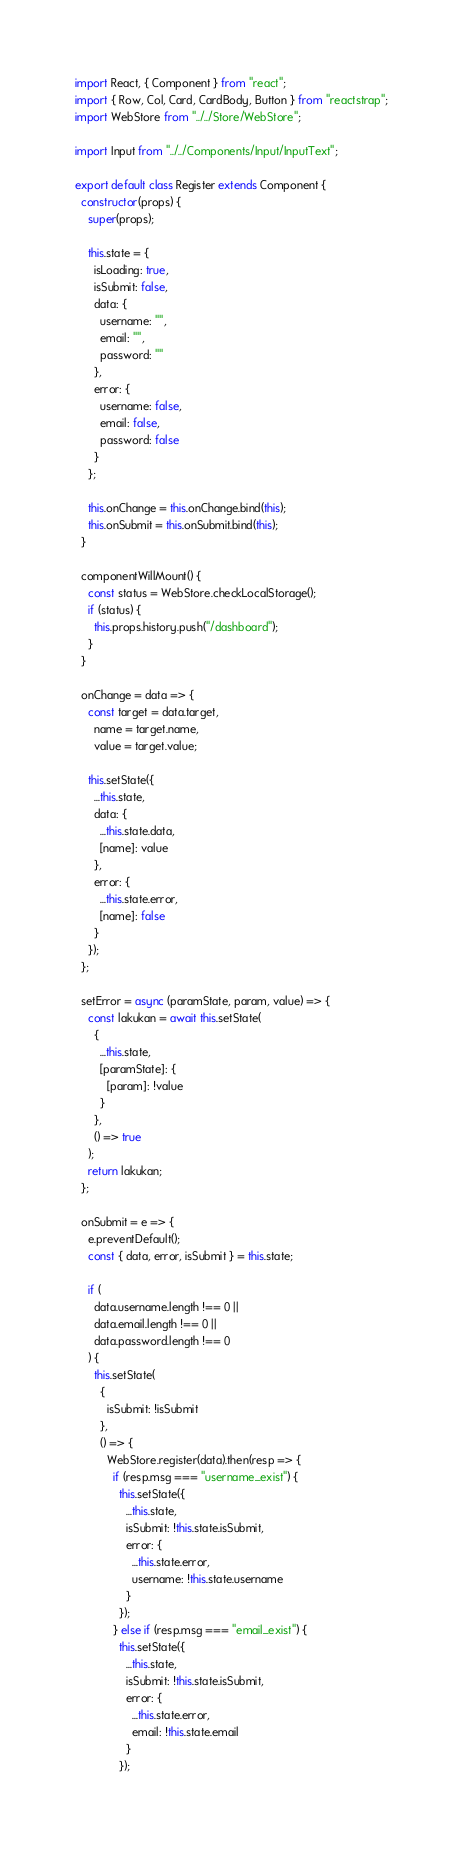Convert code to text. <code><loc_0><loc_0><loc_500><loc_500><_JavaScript_>import React, { Component } from "react";
import { Row, Col, Card, CardBody, Button } from "reactstrap";
import WebStore from "../../Store/WebStore";

import Input from "../../Components/Input/InputText";

export default class Register extends Component {
  constructor(props) {
    super(props);

    this.state = {
      isLoading: true,
      isSubmit: false,
      data: {
        username: "",
        email: "",
        password: ""
      },
      error: {
        username: false,
        email: false,
        password: false
      }
    };

    this.onChange = this.onChange.bind(this);
    this.onSubmit = this.onSubmit.bind(this);
  }

  componentWillMount() {
    const status = WebStore.checkLocalStorage();
    if (status) {
      this.props.history.push("/dashboard");
    }
  }

  onChange = data => {
    const target = data.target,
      name = target.name,
      value = target.value;

    this.setState({
      ...this.state,
      data: {
        ...this.state.data,
        [name]: value
      },
      error: {
        ...this.state.error,
        [name]: false
      }
    });
  };

  setError = async (paramState, param, value) => {
    const lakukan = await this.setState(
      {
        ...this.state,
        [paramState]: {
          [param]: !value
        }
      },
      () => true
    );
    return lakukan;
  };

  onSubmit = e => {
    e.preventDefault();
    const { data, error, isSubmit } = this.state;

    if (
      data.username.length !== 0 ||
      data.email.length !== 0 ||
      data.password.length !== 0
    ) {
      this.setState(
        {
          isSubmit: !isSubmit
        },
        () => {
          WebStore.register(data).then(resp => {
            if (resp.msg === "username_exist") {
              this.setState({
                ...this.state,
                isSubmit: !this.state.isSubmit,
                error: {
                  ...this.state.error,
                  username: !this.state.username
                }
              });
            } else if (resp.msg === "email_exist") {
              this.setState({
                ...this.state,
                isSubmit: !this.state.isSubmit,
                error: {
                  ...this.state.error,
                  email: !this.state.email
                }
              });</code> 